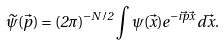<formula> <loc_0><loc_0><loc_500><loc_500>\widetilde { \psi } ( \vec { p } ) = ( 2 \pi ) ^ { - N / 2 } \int \psi ( \vec { x } ) e ^ { - i \vec { p } \vec { x } } \, d \vec { x } .</formula> 